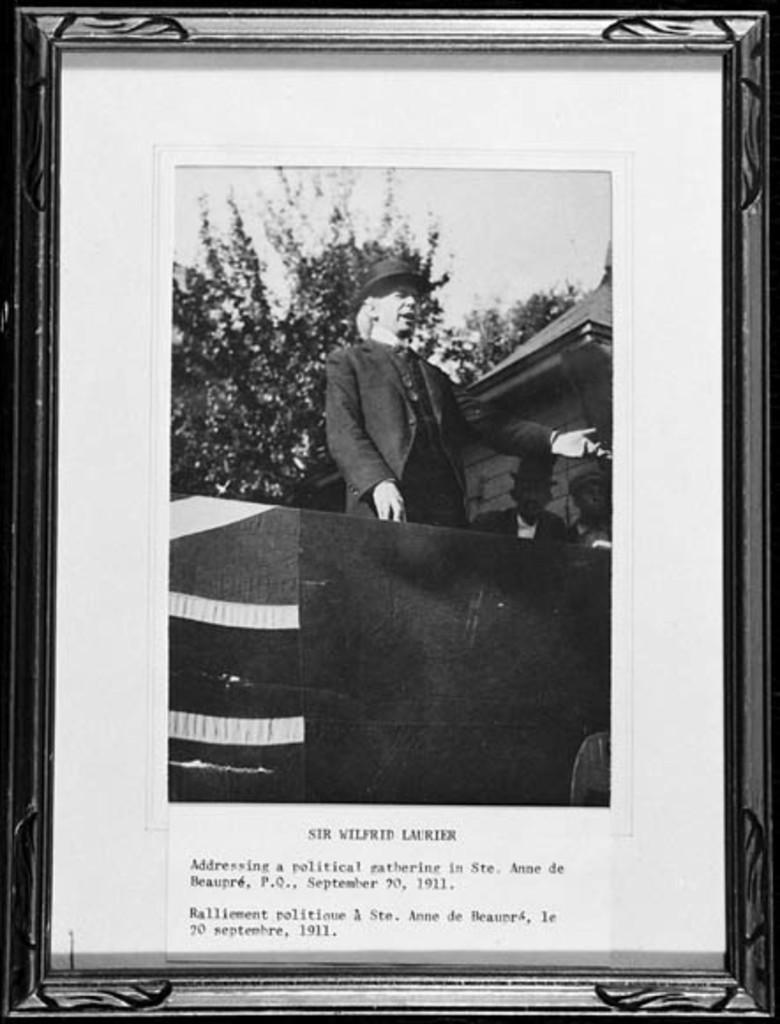<image>
Provide a brief description of the given image. a man in a photo that mentions Wilfred in it 